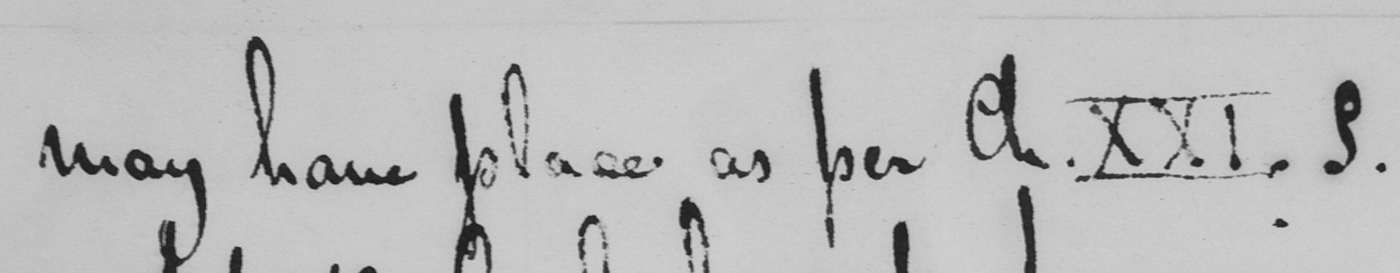Please provide the text content of this handwritten line. may have place as per Ch . XXI . § . 